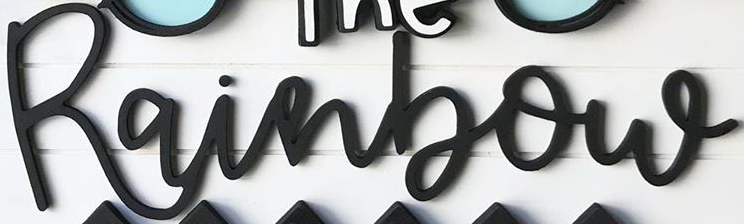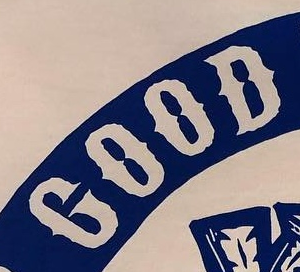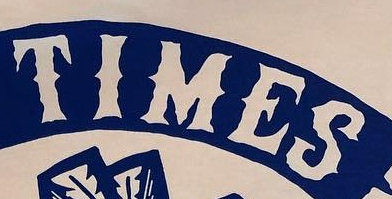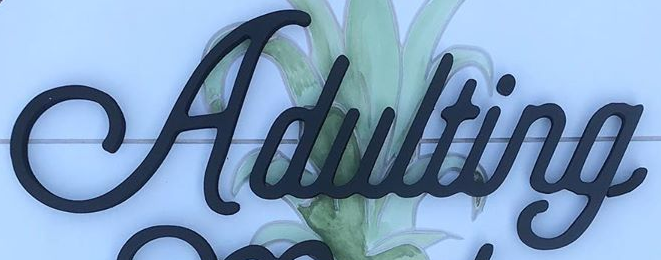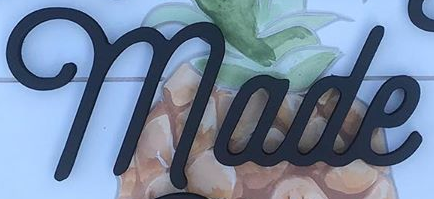Read the text content from these images in order, separated by a semicolon. Rainbow; GOOD; TIMES; Adulting; made 